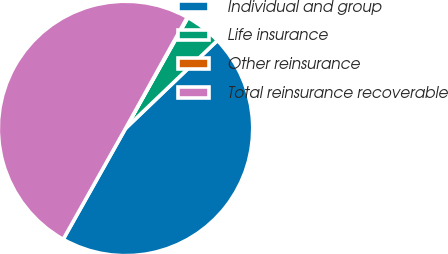Convert chart to OTSL. <chart><loc_0><loc_0><loc_500><loc_500><pie_chart><fcel>Individual and group<fcel>Life insurance<fcel>Other reinsurance<fcel>Total reinsurance recoverable<nl><fcel>45.31%<fcel>4.69%<fcel>0.09%<fcel>49.91%<nl></chart> 